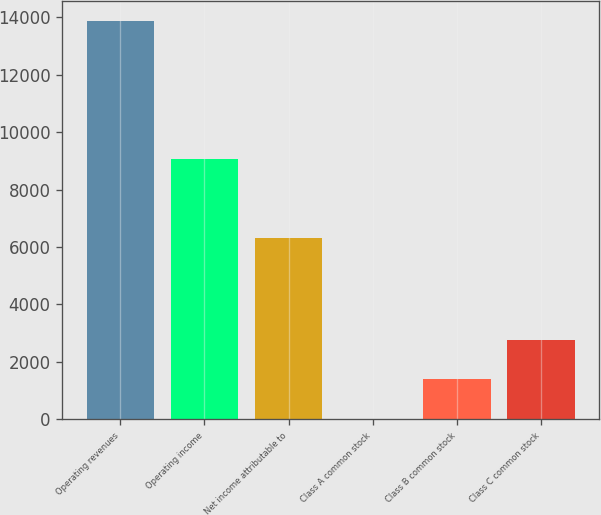Convert chart. <chart><loc_0><loc_0><loc_500><loc_500><bar_chart><fcel>Operating revenues<fcel>Operating income<fcel>Net income attributable to<fcel>Class A common stock<fcel>Class B common stock<fcel>Class C common stock<nl><fcel>13880<fcel>9064<fcel>6328<fcel>2.58<fcel>1390.32<fcel>2778.06<nl></chart> 